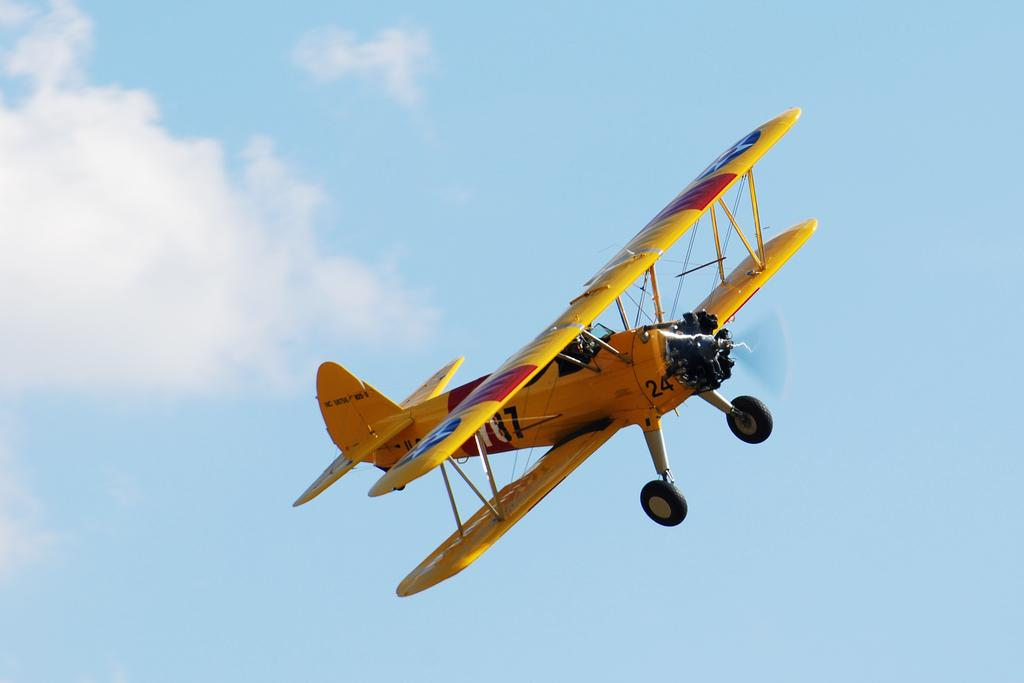What is the main subject of the image? The main subject of the image is an aircraft. Can you describe the position of the aircraft in the image? The aircraft is in the air in the image. What can be seen in the background of the image? The sky is visible in the image. Based on the visibility of the sky, can you make any assumptions about the time of day? The image is likely taken during the day, as the sky is clearly visible. How many tents can be seen set up near the aircraft in the image? There are no tents present in the image; it only features an aircraft in the air. What type of arm is visible on the aircraft in the image? There are no arms visible on the aircraft in the image, as it is a machine and not a living being. 